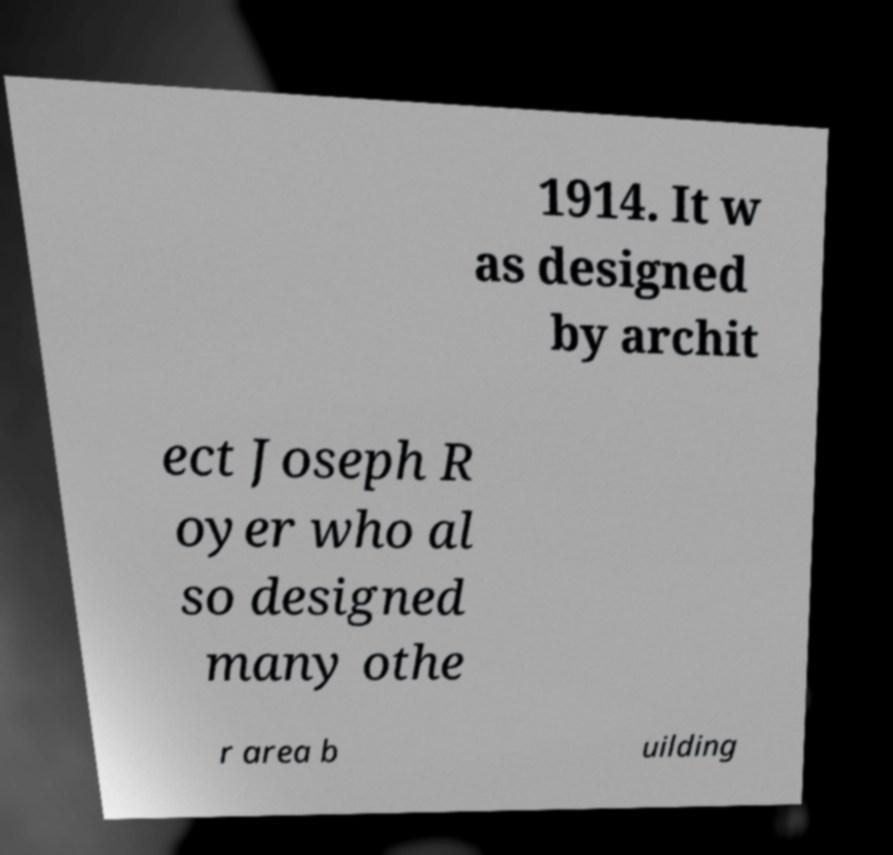Please read and relay the text visible in this image. What does it say? 1914. It w as designed by archit ect Joseph R oyer who al so designed many othe r area b uilding 